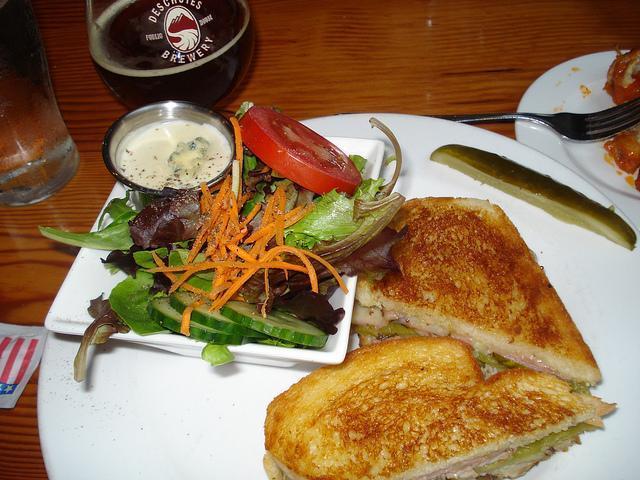How many tomato slices are on the salad?
Give a very brief answer. 1. How many sandwiches are in the photo?
Give a very brief answer. 2. How many cups are there?
Give a very brief answer. 2. 